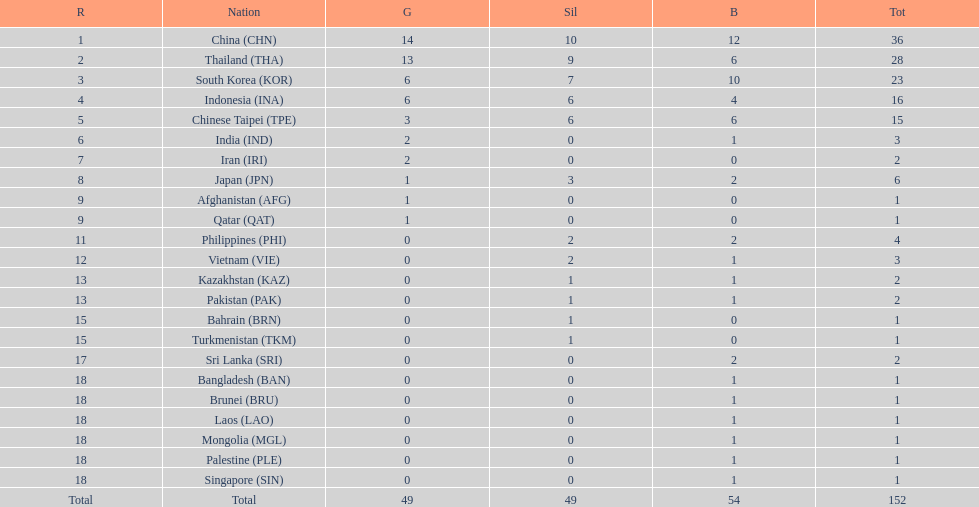How many nations received more than 5 gold medals? 4. 